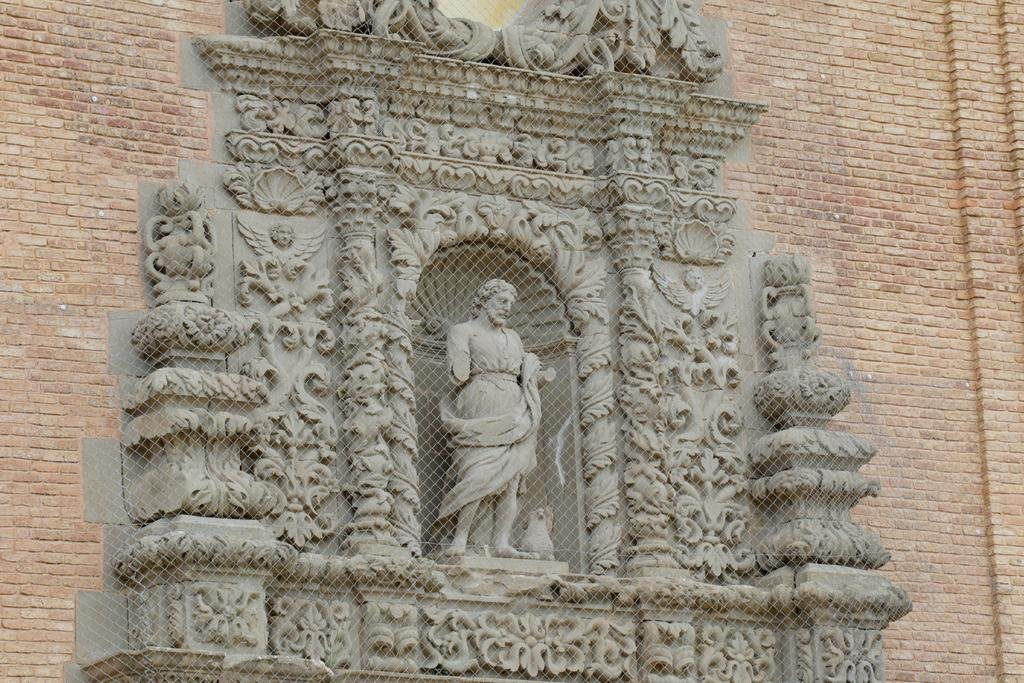What type of structure is visible in the picture? There is a brick wall in the picture. What is the main subject of the sculpture in the center of the picture? The sculpture features flowers and a human in the center. What can be seen in the foreground of the picture? There is fencing in the foreground of the picture. What type of apparel is the rabbit wearing in the picture? There is no rabbit present in the picture, so it is not possible to determine what apparel it might be wearing. What type of flooring can be seen in the picture? The provided facts do not mention any flooring in the picture, so it is not possible to determine the type of flooring. 